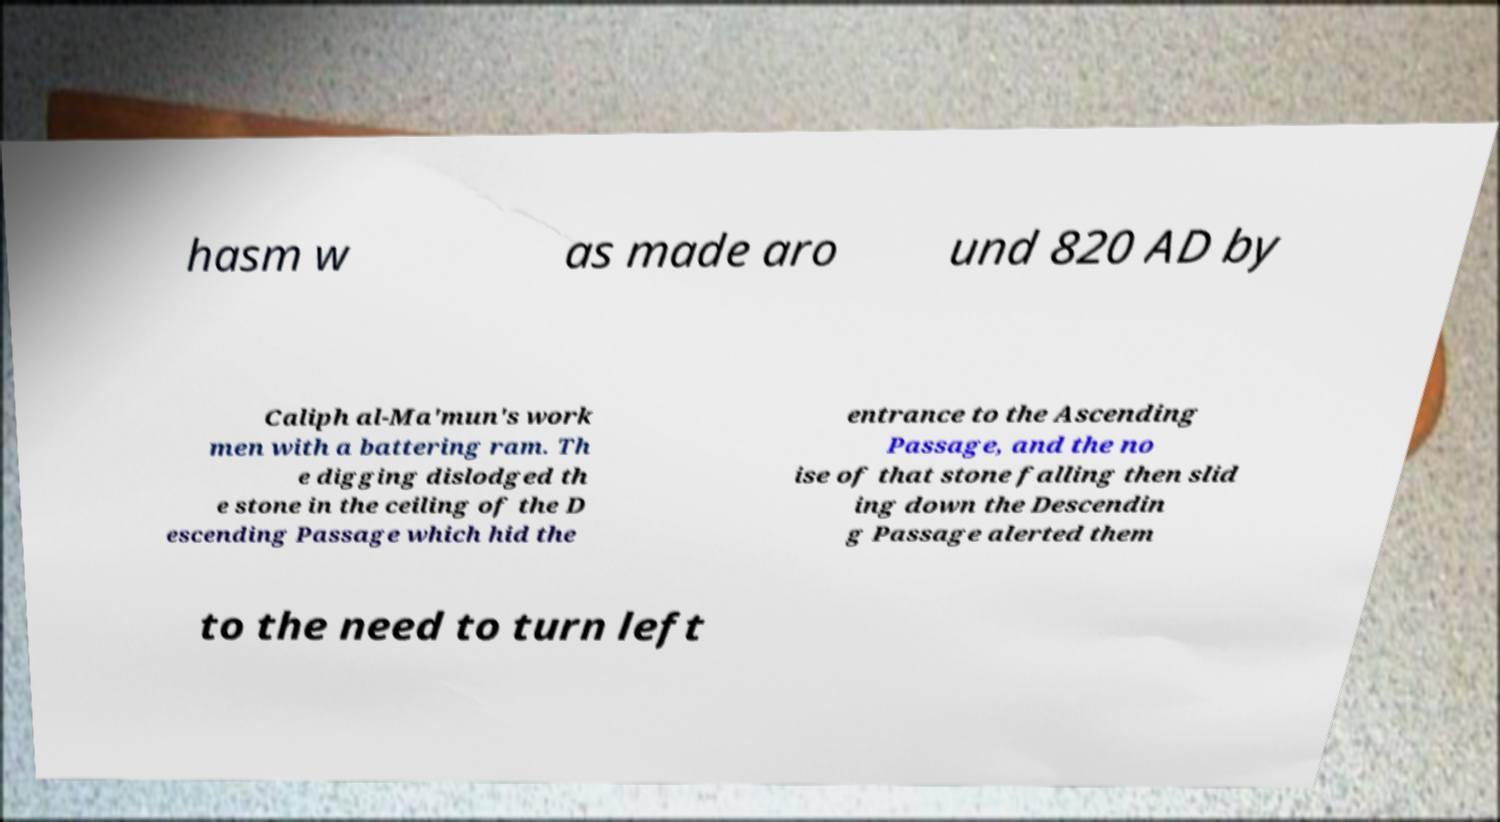There's text embedded in this image that I need extracted. Can you transcribe it verbatim? hasm w as made aro und 820 AD by Caliph al-Ma'mun's work men with a battering ram. Th e digging dislodged th e stone in the ceiling of the D escending Passage which hid the entrance to the Ascending Passage, and the no ise of that stone falling then slid ing down the Descendin g Passage alerted them to the need to turn left 